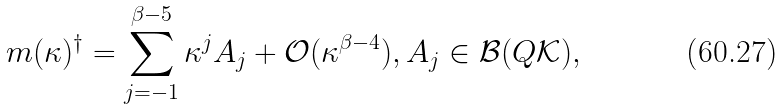<formula> <loc_0><loc_0><loc_500><loc_500>m ( \kappa ) ^ { \dagger } = \sum _ { j = - 1 } ^ { \beta - 5 } \kappa ^ { j } A _ { j } + \mathcal { O } ( \kappa ^ { \beta - 4 } ) , A _ { j } \in \mathcal { B } ( Q \mathcal { K } ) ,</formula> 